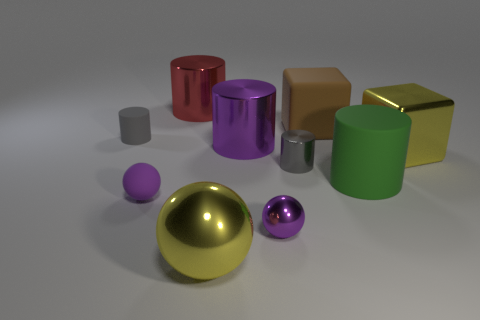What number of objects are either big yellow shiny balls or brown things?
Make the answer very short. 2. What shape is the tiny object that is both in front of the big yellow block and behind the green matte thing?
Provide a short and direct response. Cylinder. How many big yellow things are there?
Ensure brevity in your answer.  2. There is a block that is made of the same material as the big purple object; what is its color?
Offer a very short reply. Yellow. Are there more tiny shiny objects than metallic cylinders?
Provide a short and direct response. No. What size is the rubber thing that is both on the left side of the small gray metallic object and in front of the large yellow block?
Your answer should be compact. Small. What material is the small thing that is the same color as the tiny metal cylinder?
Your answer should be very brief. Rubber. Are there an equal number of big things behind the brown cube and big objects?
Make the answer very short. No. Is the gray shiny cylinder the same size as the purple cylinder?
Your answer should be compact. No. What is the color of the large object that is to the right of the gray metallic object and in front of the metallic block?
Offer a terse response. Green. 